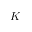<formula> <loc_0><loc_0><loc_500><loc_500>K</formula> 